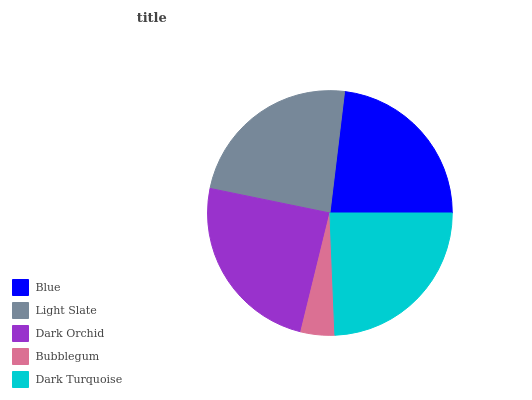Is Bubblegum the minimum?
Answer yes or no. Yes. Is Dark Orchid the maximum?
Answer yes or no. Yes. Is Light Slate the minimum?
Answer yes or no. No. Is Light Slate the maximum?
Answer yes or no. No. Is Light Slate greater than Blue?
Answer yes or no. Yes. Is Blue less than Light Slate?
Answer yes or no. Yes. Is Blue greater than Light Slate?
Answer yes or no. No. Is Light Slate less than Blue?
Answer yes or no. No. Is Light Slate the high median?
Answer yes or no. Yes. Is Light Slate the low median?
Answer yes or no. Yes. Is Bubblegum the high median?
Answer yes or no. No. Is Bubblegum the low median?
Answer yes or no. No. 